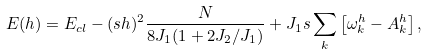<formula> <loc_0><loc_0><loc_500><loc_500>E ( h ) = E _ { c l } - ( s h ) ^ { 2 } \frac { N } { 8 J _ { 1 } ( 1 + 2 J _ { 2 } / J _ { 1 } ) } + J _ { 1 } s \sum _ { k } \left [ \omega _ { k } ^ { h } - A _ { k } ^ { h } \right ] ,</formula> 